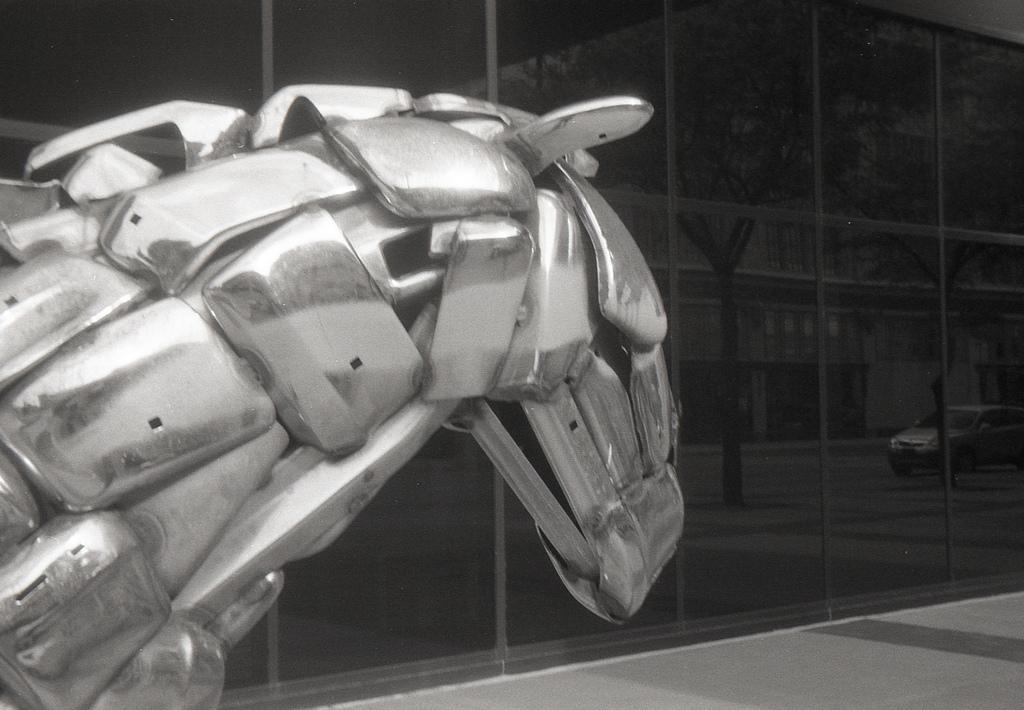How would you summarize this image in a sentence or two? In this image we can see a metallic object, there we can see a glass wall, on the glass wall we see the reflections of the vehicle, tree and buildings. 